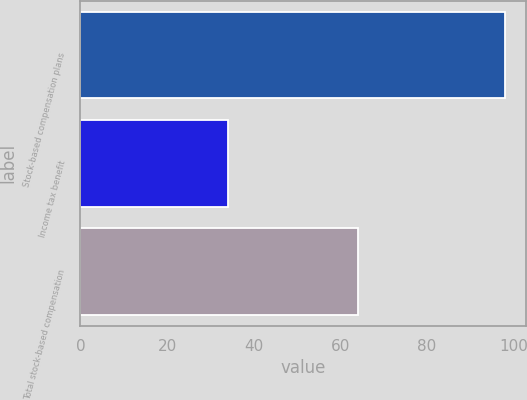Convert chart. <chart><loc_0><loc_0><loc_500><loc_500><bar_chart><fcel>Stock-based compensation plans<fcel>Income tax benefit<fcel>Total stock-based compensation<nl><fcel>98<fcel>34<fcel>64<nl></chart> 